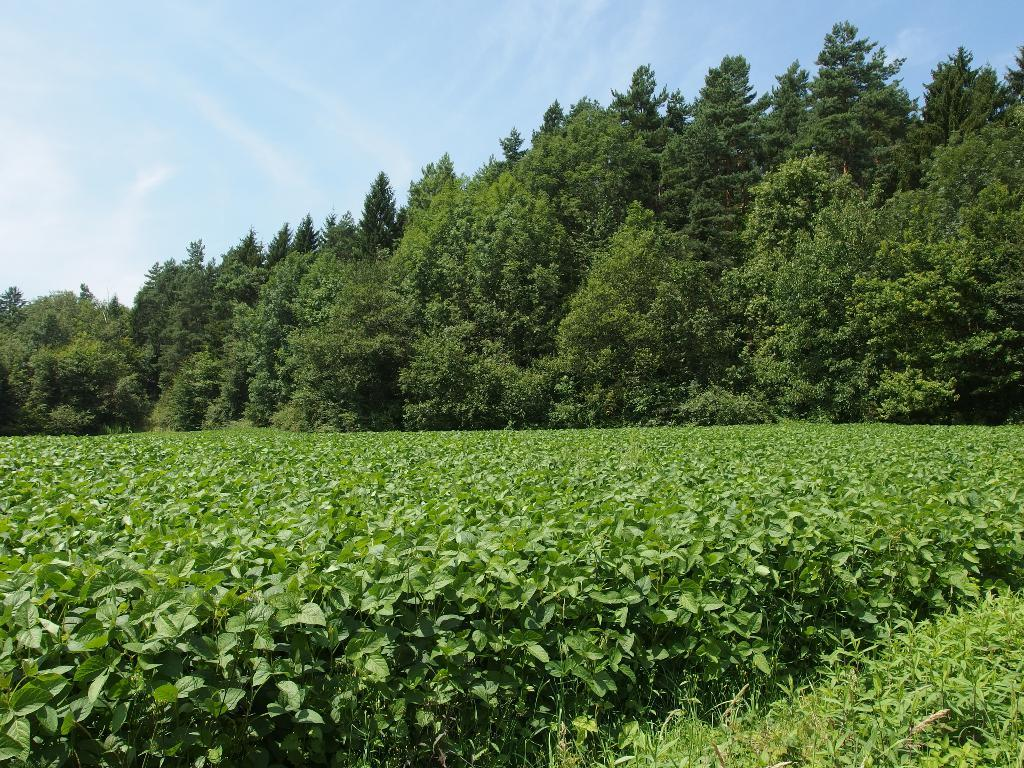What type of vegetation is present in the image? There are green plants in the image. What can be seen in the background of the image? There are trees and the sky visible in the background of the image. What type of error can be seen in the image? There is no error present in the image; it is a scene featuring green plants, trees, and the sky. 